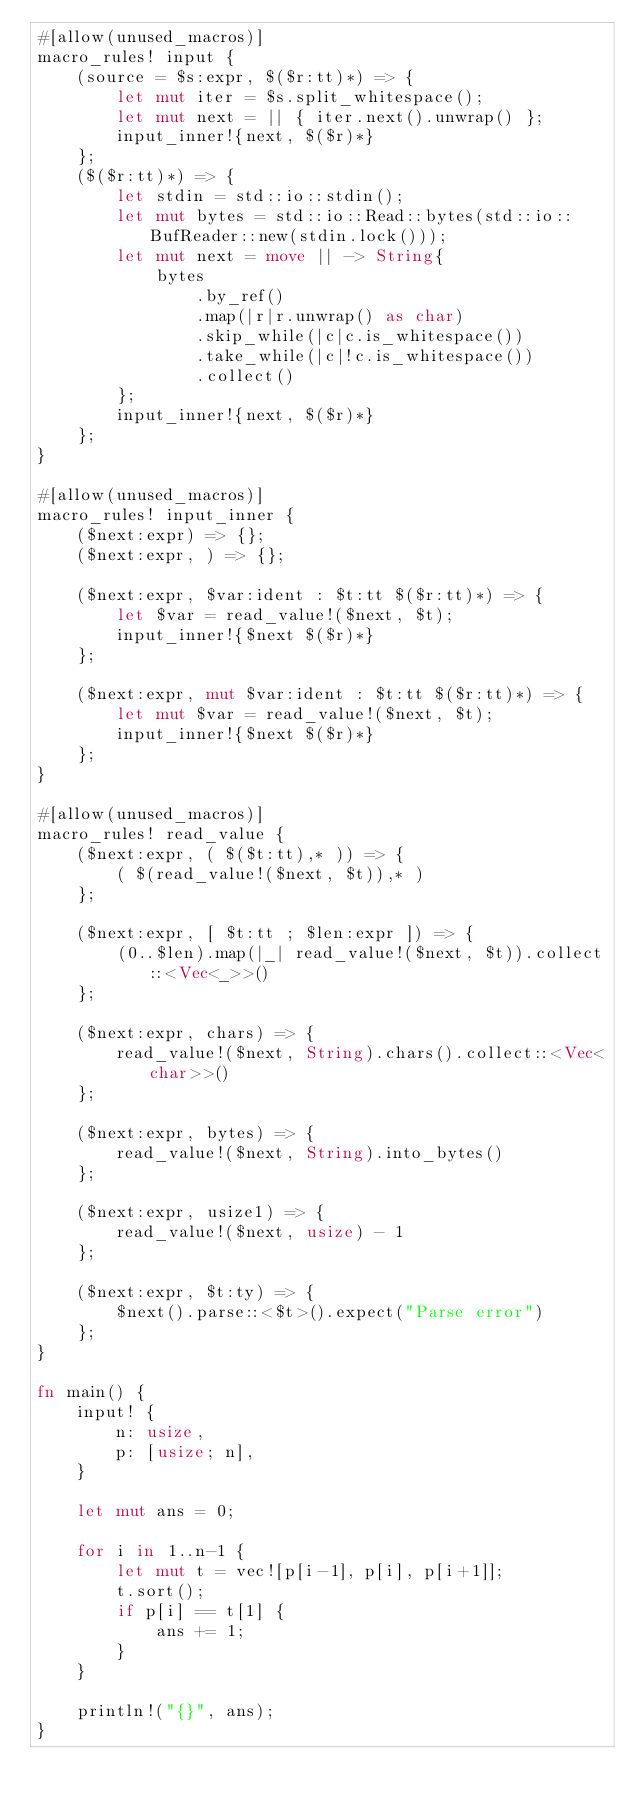Convert code to text. <code><loc_0><loc_0><loc_500><loc_500><_Rust_>#[allow(unused_macros)]
macro_rules! input {
    (source = $s:expr, $($r:tt)*) => {
        let mut iter = $s.split_whitespace();
        let mut next = || { iter.next().unwrap() };
        input_inner!{next, $($r)*}
    };
    ($($r:tt)*) => {
        let stdin = std::io::stdin();
        let mut bytes = std::io::Read::bytes(std::io::BufReader::new(stdin.lock()));
        let mut next = move || -> String{
            bytes
                .by_ref()
                .map(|r|r.unwrap() as char)
                .skip_while(|c|c.is_whitespace())
                .take_while(|c|!c.is_whitespace())
                .collect()
        };
        input_inner!{next, $($r)*}
    };
}

#[allow(unused_macros)]
macro_rules! input_inner {
    ($next:expr) => {};
    ($next:expr, ) => {};

    ($next:expr, $var:ident : $t:tt $($r:tt)*) => {
        let $var = read_value!($next, $t);
        input_inner!{$next $($r)*}
    };

    ($next:expr, mut $var:ident : $t:tt $($r:tt)*) => {
        let mut $var = read_value!($next, $t);
        input_inner!{$next $($r)*}
    };
}

#[allow(unused_macros)]
macro_rules! read_value {
    ($next:expr, ( $($t:tt),* )) => {
        ( $(read_value!($next, $t)),* )
    };

    ($next:expr, [ $t:tt ; $len:expr ]) => {
        (0..$len).map(|_| read_value!($next, $t)).collect::<Vec<_>>()
    };

    ($next:expr, chars) => {
        read_value!($next, String).chars().collect::<Vec<char>>()
    };

    ($next:expr, bytes) => {
        read_value!($next, String).into_bytes()
    };

    ($next:expr, usize1) => {
        read_value!($next, usize) - 1
    };

    ($next:expr, $t:ty) => {
        $next().parse::<$t>().expect("Parse error")
    };
}

fn main() {
    input! {
        n: usize,
        p: [usize; n],
    }

    let mut ans = 0;

    for i in 1..n-1 {
        let mut t = vec![p[i-1], p[i], p[i+1]];
        t.sort();
        if p[i] == t[1] {
            ans += 1;
        }
    }

    println!("{}", ans);
}
</code> 